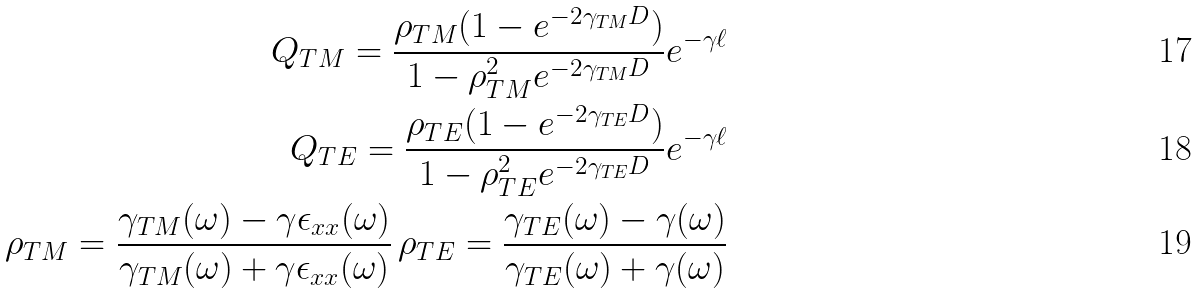Convert formula to latex. <formula><loc_0><loc_0><loc_500><loc_500>Q _ { T M } = \frac { \rho _ { T M } ( 1 - e ^ { - 2 \gamma _ { T M } D } ) } { 1 - \rho _ { T M } ^ { 2 } e ^ { - 2 \gamma _ { T M } D } } e ^ { - \gamma \ell } \\ Q _ { T E } = \frac { \rho _ { T E } ( 1 - e ^ { - 2 \gamma _ { T E } D } ) } { 1 - \rho _ { T E } ^ { 2 } e ^ { - 2 \gamma _ { T E } D } } e ^ { - \gamma \ell } \\ \rho _ { T M } = \frac { \gamma _ { T M } ( \omega ) - \gamma \epsilon _ { x x } ( \omega ) } { \gamma _ { T M } ( \omega ) + \gamma \epsilon _ { x x } ( \omega ) } \, \rho _ { T E } = \frac { \gamma _ { T E } ( \omega ) - \gamma ( \omega ) } { \gamma _ { T E } ( \omega ) + \gamma ( \omega ) }</formula> 